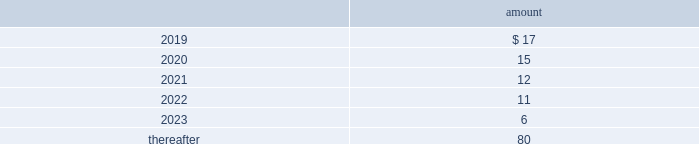The table provides the minimum annual future rental commitment under operating leases that have initial or remaining non-cancelable lease terms over the next five years and thereafter: .
The company has a series of agreements with various public entities ( the 201cpartners 201d ) to establish certain joint ventures , commonly referred to as 201cpublic-private partnerships . 201d under the public-private partnerships , the company constructed utility plant , financed by the company , and the partners constructed utility plant ( connected to the company 2019s property ) , financed by the partners .
The company agreed to transfer and convey some of its real and personal property to the partners in exchange for an equal principal amount of industrial development bonds ( 201cidbs 201d ) , issued by the partners under a state industrial development bond and commercial development act .
The company leased back the total facilities , including portions funded by both the company and the partners , under leases for a period of 40 years .
The leases related to the portion of the facilities funded by the company have required payments from the company to the partners that approximate the payments required by the terms of the idbs from the partners to the company ( as the holder of the idbs ) .
As the ownership of the portion of the facilities constructed by the company will revert back to the company at the end of the lease , the company has recorded these as capital leases .
The lease obligation and the receivable for the principal amount of the idbs are presented by the company on a net basis .
The carrying value of the facilities funded by the company recognized as a capital lease asset was $ 147 million and $ 150 million as of december 31 , 2018 and 2017 , respectively , which is presented in property , plant and equipment on the consolidated balance sheets .
The future payments under the lease obligations are equal to and offset by the payments receivable under the idbs .
As of december 31 , 2018 , the minimum annual future rental commitment under the operating leases for the portion of the facilities funded by the partners that have initial or remaining non-cancelable lease terms in excess of one year included in the preceding minimum annual rental commitments are $ 4 million in 2019 through 2023 , and $ 59 million thereafter .
Note 20 : segment information the company 2019s operating segments are comprised of the revenue-generating components of its businesses for which separate financial information is internally produced and regularly used by management to make operating decisions and assess performance .
The company operates its businesses primarily through one reportable segment , the regulated businesses segment .
The company also operates market-based businesses that provide a broad range of related and complementary water and wastewater services within non-reportable operating segments , collectively referred to as the market-based businesses .
The regulated businesses segment is the largest component of the company 2019s business and includes 20 subsidiaries that provide water and wastewater services to customers in 16 states .
The company 2019s primary market-based businesses include the homeowner services group , which provides warranty protection programs to residential and smaller commercial customers ; the military services group , which provides water and wastewater services to the u.s .
Government on military installations ; and keystone , which provides water transfer services for shale natural gas exploration and production companies. .
What percentage of the minimum annual future rental commitment under operating leases that have initial or remaining non-cancelable lease terms is due after 2023? 
Rationale: from here you need to take the total due after 2023 , or 80 , and divide it by the total or 141 to get 56.7%
Computations: (((17 + 15) + (12 + 11)) + (6 + 80))
Answer: 141.0. 